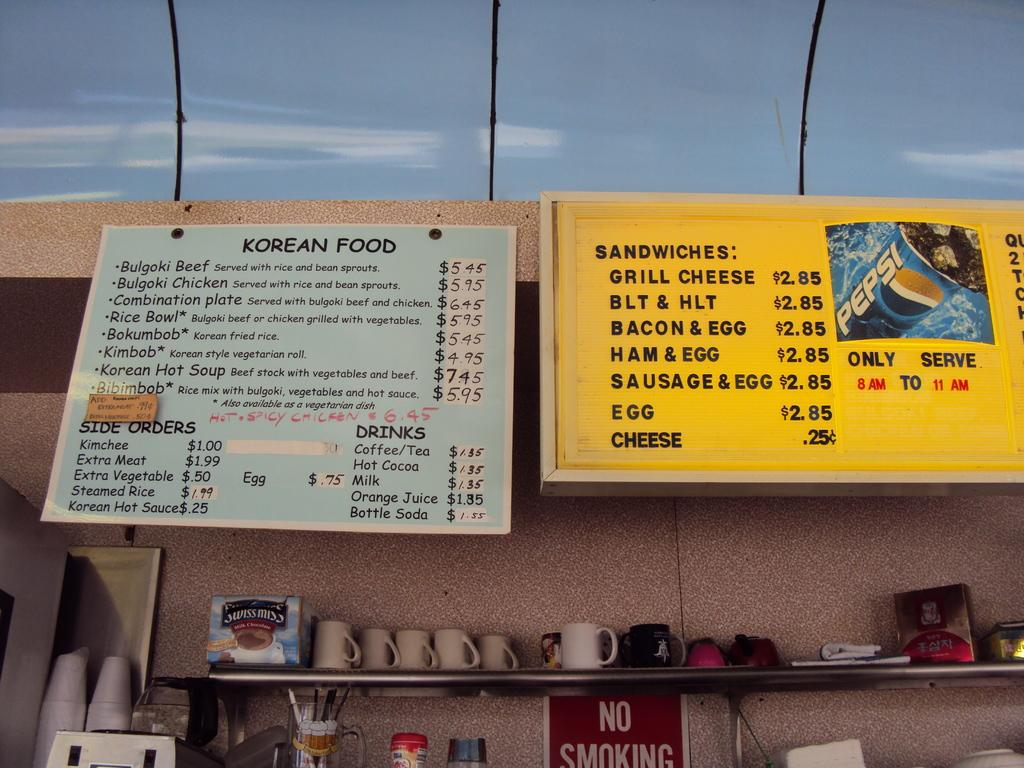<image>
Share a concise interpretation of the image provided. The menu signs on the wall list a variety of Korean foods as well as American classics like grilled cheese, BLT, and bacon and egg sandwich. 